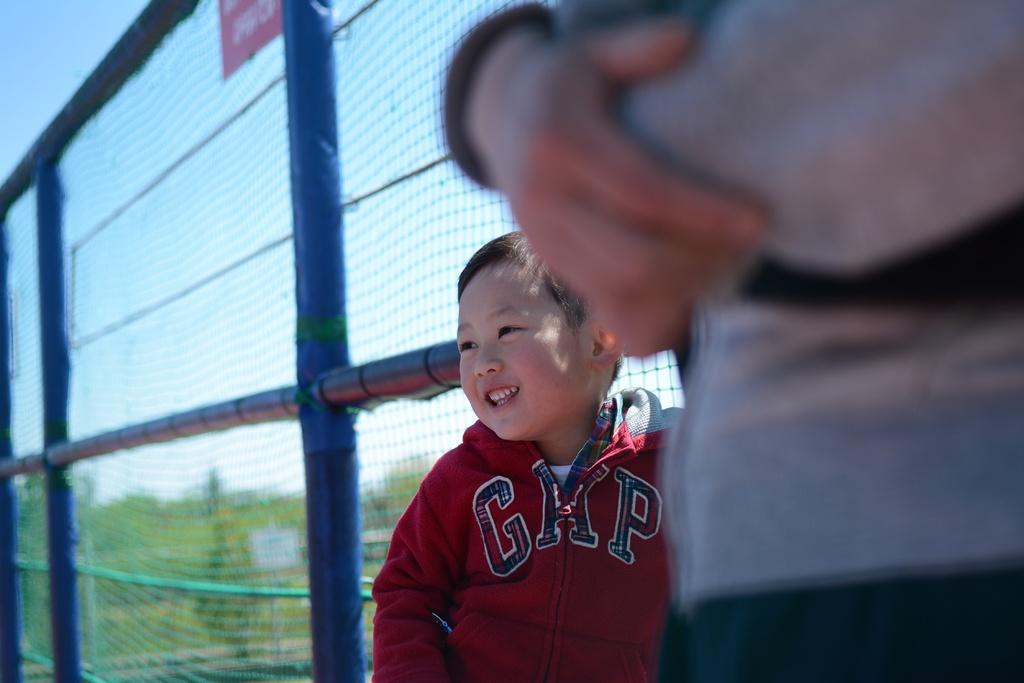<image>
Render a clear and concise summary of the photo. A little boy in a red GAP jacket standing by a fence. 